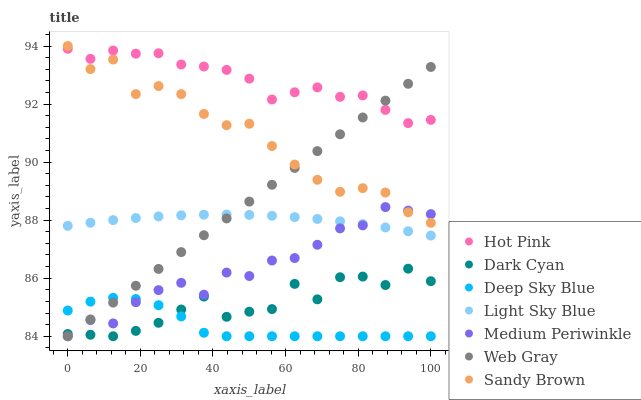Does Deep Sky Blue have the minimum area under the curve?
Answer yes or no. Yes. Does Hot Pink have the maximum area under the curve?
Answer yes or no. Yes. Does Medium Periwinkle have the minimum area under the curve?
Answer yes or no. No. Does Medium Periwinkle have the maximum area under the curve?
Answer yes or no. No. Is Web Gray the smoothest?
Answer yes or no. Yes. Is Dark Cyan the roughest?
Answer yes or no. Yes. Is Hot Pink the smoothest?
Answer yes or no. No. Is Hot Pink the roughest?
Answer yes or no. No. Does Web Gray have the lowest value?
Answer yes or no. Yes. Does Hot Pink have the lowest value?
Answer yes or no. No. Does Sandy Brown have the highest value?
Answer yes or no. Yes. Does Hot Pink have the highest value?
Answer yes or no. No. Is Dark Cyan less than Hot Pink?
Answer yes or no. Yes. Is Sandy Brown greater than Light Sky Blue?
Answer yes or no. Yes. Does Web Gray intersect Light Sky Blue?
Answer yes or no. Yes. Is Web Gray less than Light Sky Blue?
Answer yes or no. No. Is Web Gray greater than Light Sky Blue?
Answer yes or no. No. Does Dark Cyan intersect Hot Pink?
Answer yes or no. No. 